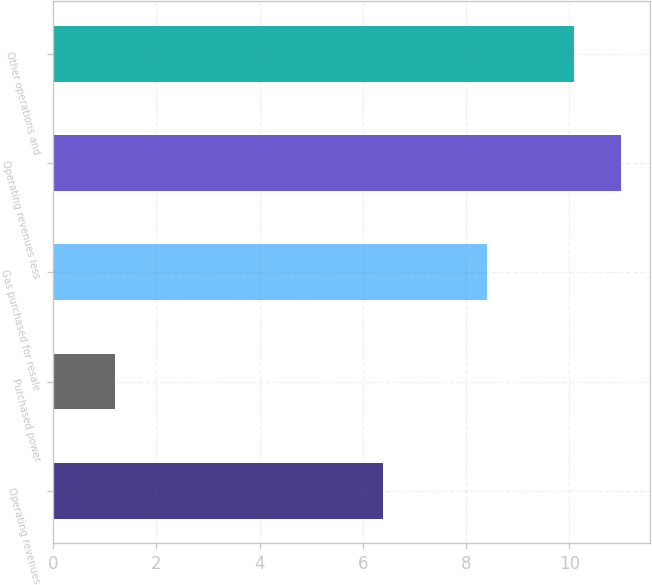Convert chart to OTSL. <chart><loc_0><loc_0><loc_500><loc_500><bar_chart><fcel>Operating revenues<fcel>Purchased power<fcel>Gas purchased for resale<fcel>Operating revenues less<fcel>Other operations and<nl><fcel>6.4<fcel>1.2<fcel>8.4<fcel>11.01<fcel>10.1<nl></chart> 